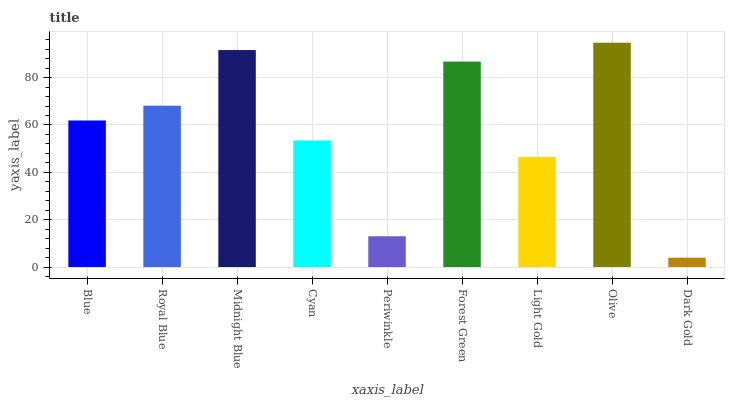Is Dark Gold the minimum?
Answer yes or no. Yes. Is Olive the maximum?
Answer yes or no. Yes. Is Royal Blue the minimum?
Answer yes or no. No. Is Royal Blue the maximum?
Answer yes or no. No. Is Royal Blue greater than Blue?
Answer yes or no. Yes. Is Blue less than Royal Blue?
Answer yes or no. Yes. Is Blue greater than Royal Blue?
Answer yes or no. No. Is Royal Blue less than Blue?
Answer yes or no. No. Is Blue the high median?
Answer yes or no. Yes. Is Blue the low median?
Answer yes or no. Yes. Is Olive the high median?
Answer yes or no. No. Is Royal Blue the low median?
Answer yes or no. No. 